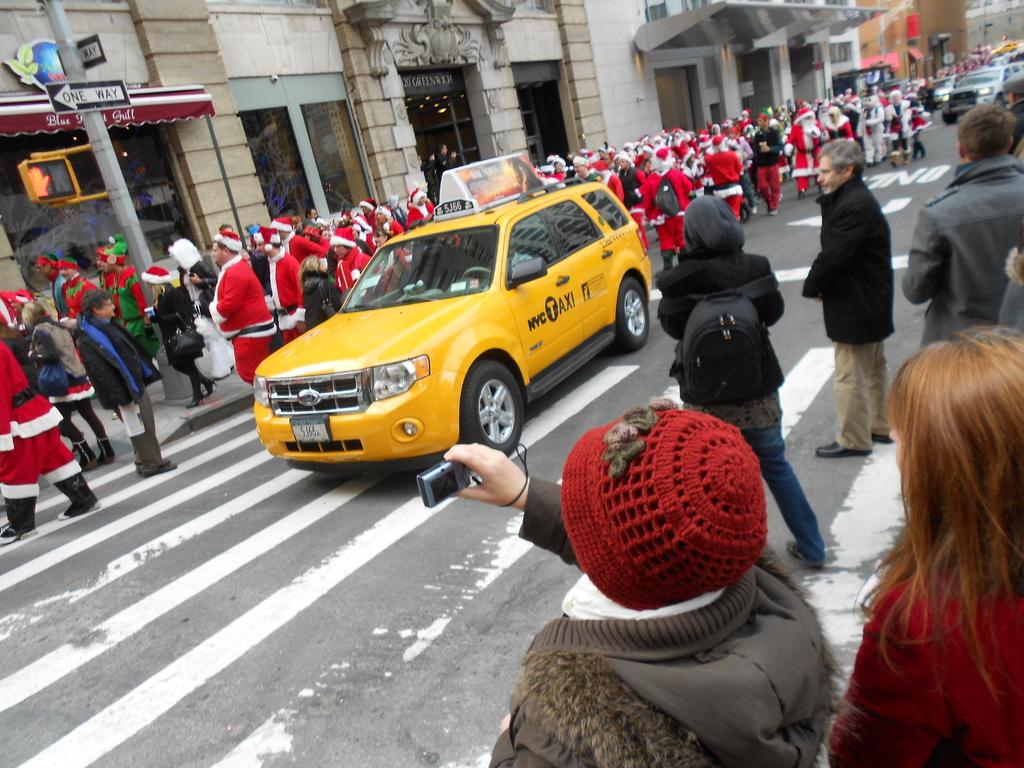What is the medallion number for this taxi?
Offer a very short reply. 5j66. What is the sign in the top left indicating?
Offer a terse response. One way. 